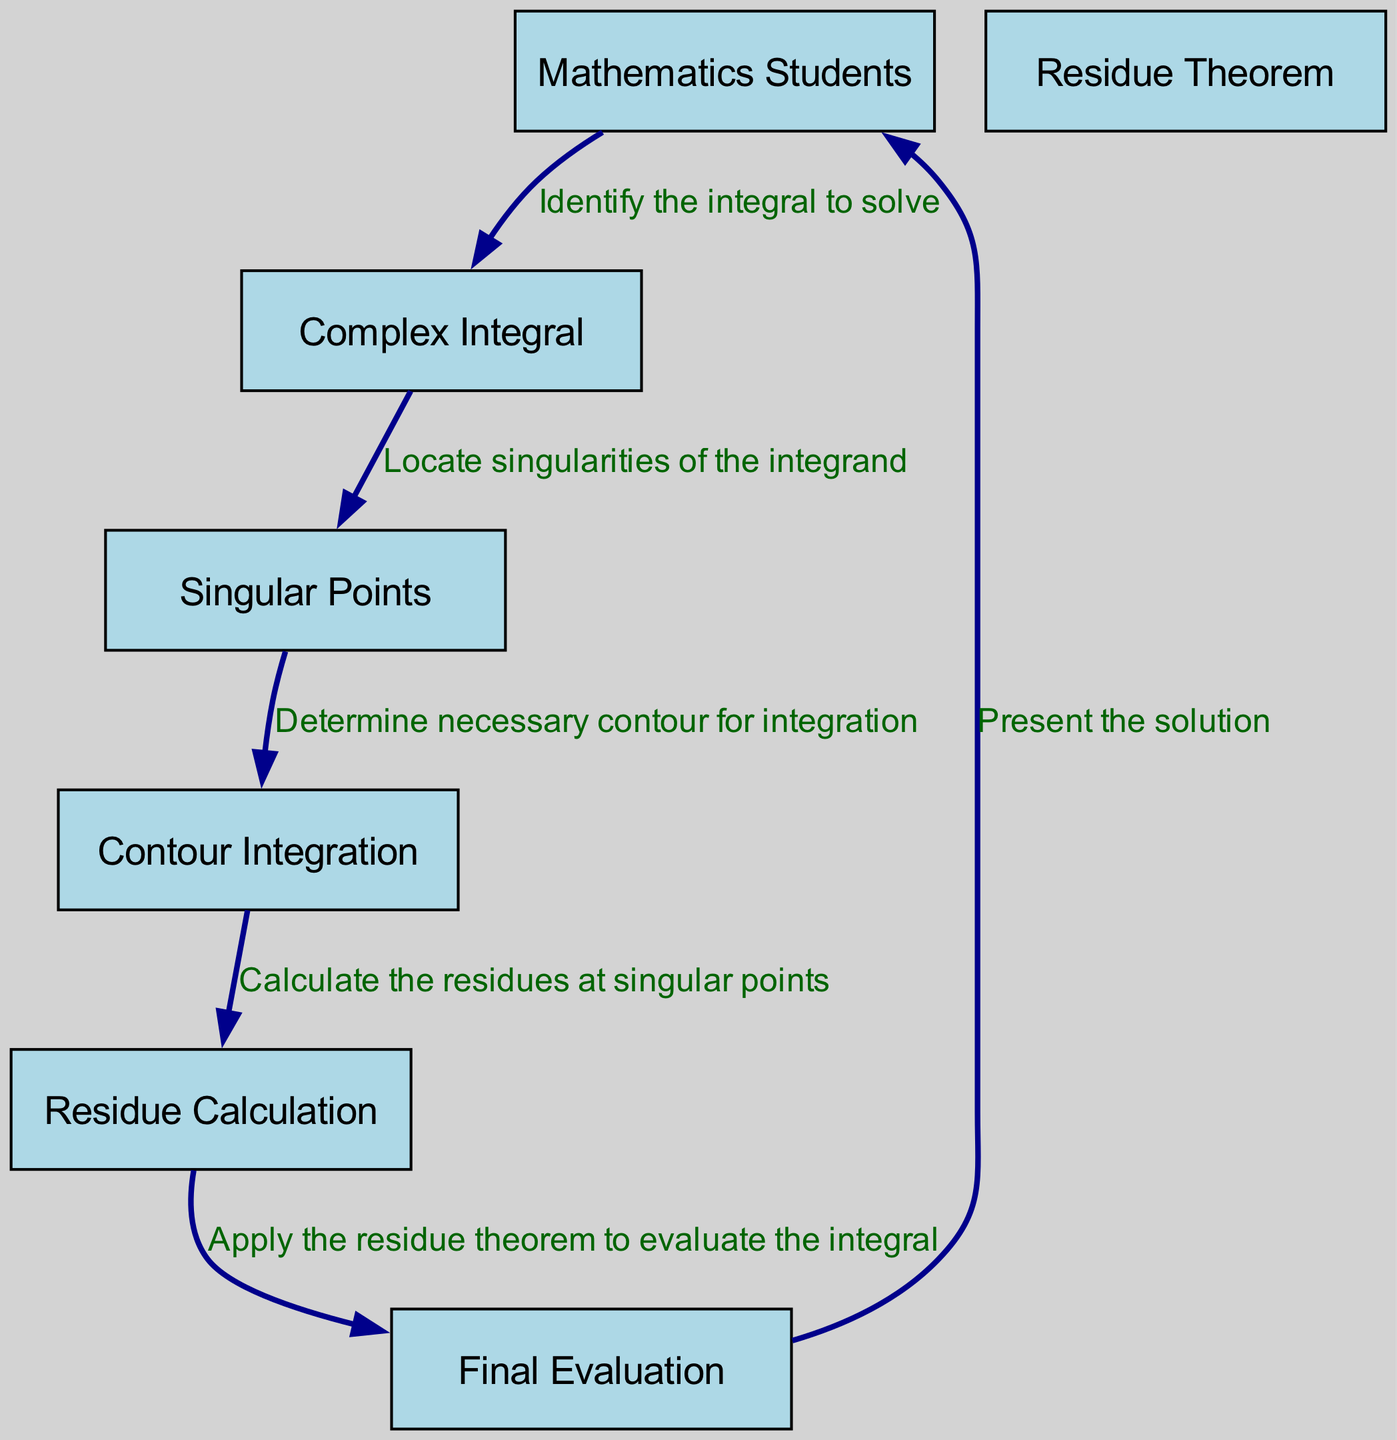What is the first action taken by the Mathematics Students? The first action in the sequence diagram is initiated by the Mathematics Students, who identify the integral to solve. This is the starting point of the interaction.
Answer: Identify the integral to solve How many participants are present in the diagram? The diagram lists seven different participants involved in the process of solving the complex integral. They are Mathematics Students, Complex Integral, Residue Theorem, Singular Points, Contour Integration, Residue Calculation, and Final Evaluation.
Answer: Seven What is the relationship between the Complex Integral and the Singular Points? The interaction shows that the Complex Integral locates singularities of the integrand, indicating a direct flow of information from the Complex Integral to the Singular Points.
Answer: Locate singularities of the integrand What action follows the residue calculation? After the residue calculation, the next action is to apply the residue theorem to evaluate the integral. This indicates a progression toward evaluating the overall integral based on the previously calculated residues.
Answer: Apply the residue theorem to evaluate the integral Which participant receives the final evaluation? The final evaluation action is directed back to the Mathematics Students, marking the completion of the process where the solution is presented to them.
Answer: Mathematics Students What is the sequence of steps starting from locating singular points? The sequence begins with locating singular points, followed by determining the contour for integration, then calculating residues at the singular points, and lastly applying the residue theorem for evaluation. This showcases the stepwise nature of the process.
Answer: Locate singularities, determine contour, calculate residues, apply residue theorem 